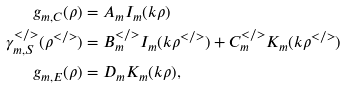Convert formula to latex. <formula><loc_0><loc_0><loc_500><loc_500>g _ { m , C } ( \rho ) & = A _ { m } I _ { m } ( k \rho ) \\ \gamma _ { m , S } ^ { < / > } ( \rho ^ { < / > } ) & = B _ { m } ^ { < / > } I _ { m } ( k \rho ^ { < / > } ) + C _ { m } ^ { < / > } K _ { m } ( k \rho ^ { < / > } ) \\ g _ { m , E } ( \rho ) & = D _ { m } K _ { m } ( k \rho ) ,</formula> 